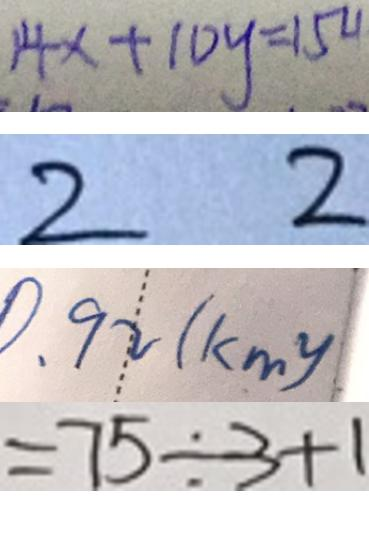Convert formula to latex. <formula><loc_0><loc_0><loc_500><loc_500>1 4 x + 1 0 y = 1 5 4 
 2 2 
 0 . 9 2 ( k m ^ { 2 } ) 
 = 7 5 \div 3 + 1</formula> 